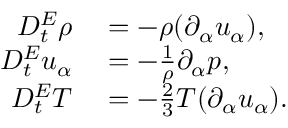Convert formula to latex. <formula><loc_0><loc_0><loc_500><loc_500>\begin{array} { r l } { D _ { t } ^ { E } \rho } & = - \rho ( \partial _ { \alpha } u _ { \alpha } ) , } \\ { D _ { t } ^ { E } u _ { \alpha } } & = - \frac { 1 } { \rho } \partial _ { \alpha } p , } \\ { D _ { t } ^ { E } T } & = - \frac { 2 } { 3 } T ( \partial _ { \alpha } u _ { \alpha } ) . } \end{array}</formula> 